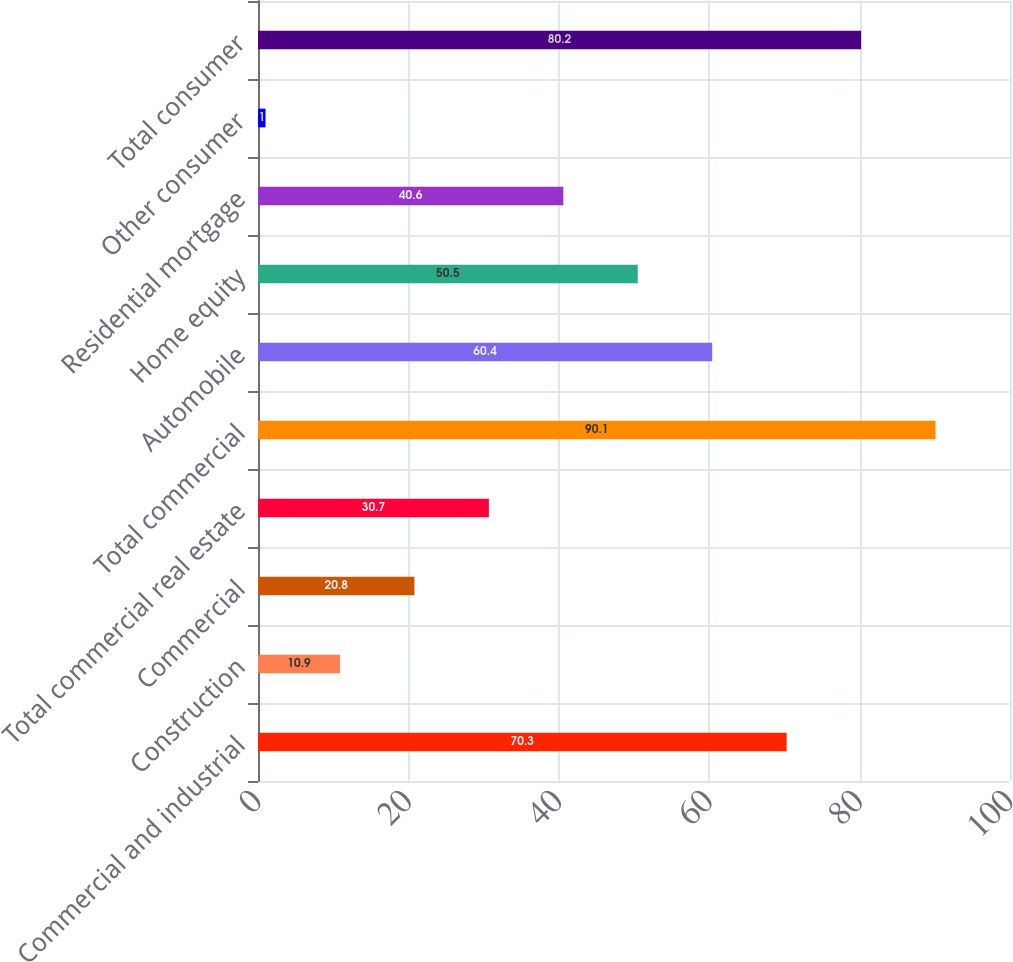Convert chart to OTSL. <chart><loc_0><loc_0><loc_500><loc_500><bar_chart><fcel>Commercial and industrial<fcel>Construction<fcel>Commercial<fcel>Total commercial real estate<fcel>Total commercial<fcel>Automobile<fcel>Home equity<fcel>Residential mortgage<fcel>Other consumer<fcel>Total consumer<nl><fcel>70.3<fcel>10.9<fcel>20.8<fcel>30.7<fcel>90.1<fcel>60.4<fcel>50.5<fcel>40.6<fcel>1<fcel>80.2<nl></chart> 